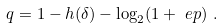<formula> <loc_0><loc_0><loc_500><loc_500>q & = 1 - h ( \delta ) - \log _ { 2 } ( { 1 + \ e p } ) \ .</formula> 